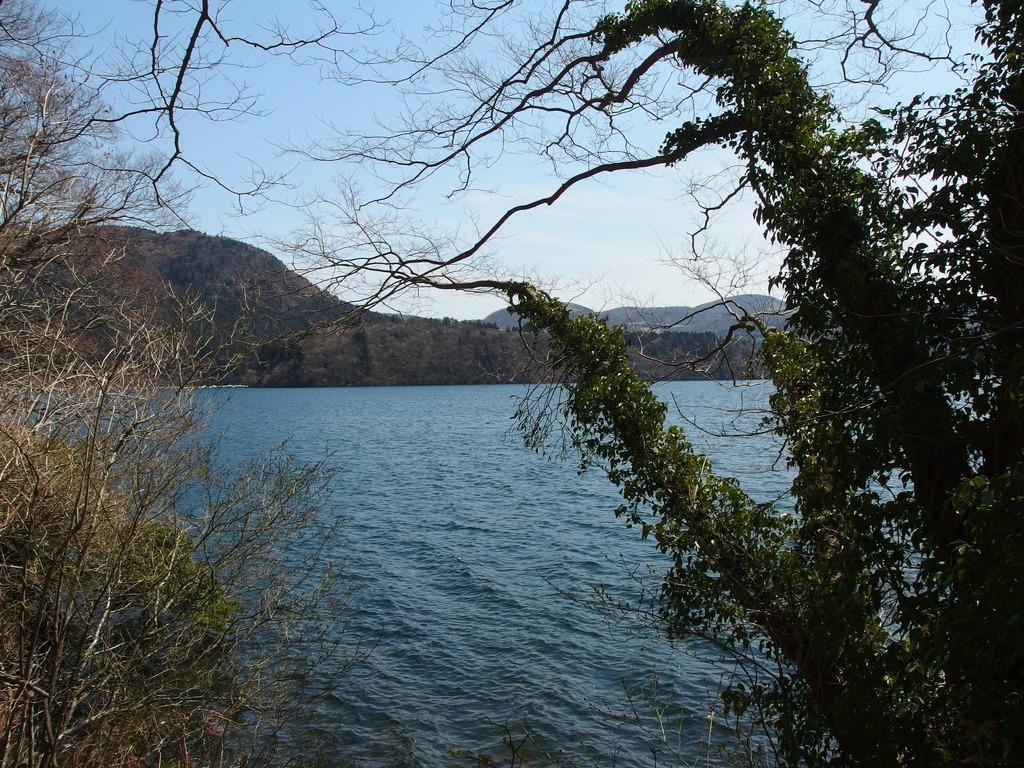Could you give a brief overview of what you see in this image? In the center of the image there is water. In the background there are trees, mountains and sky. 